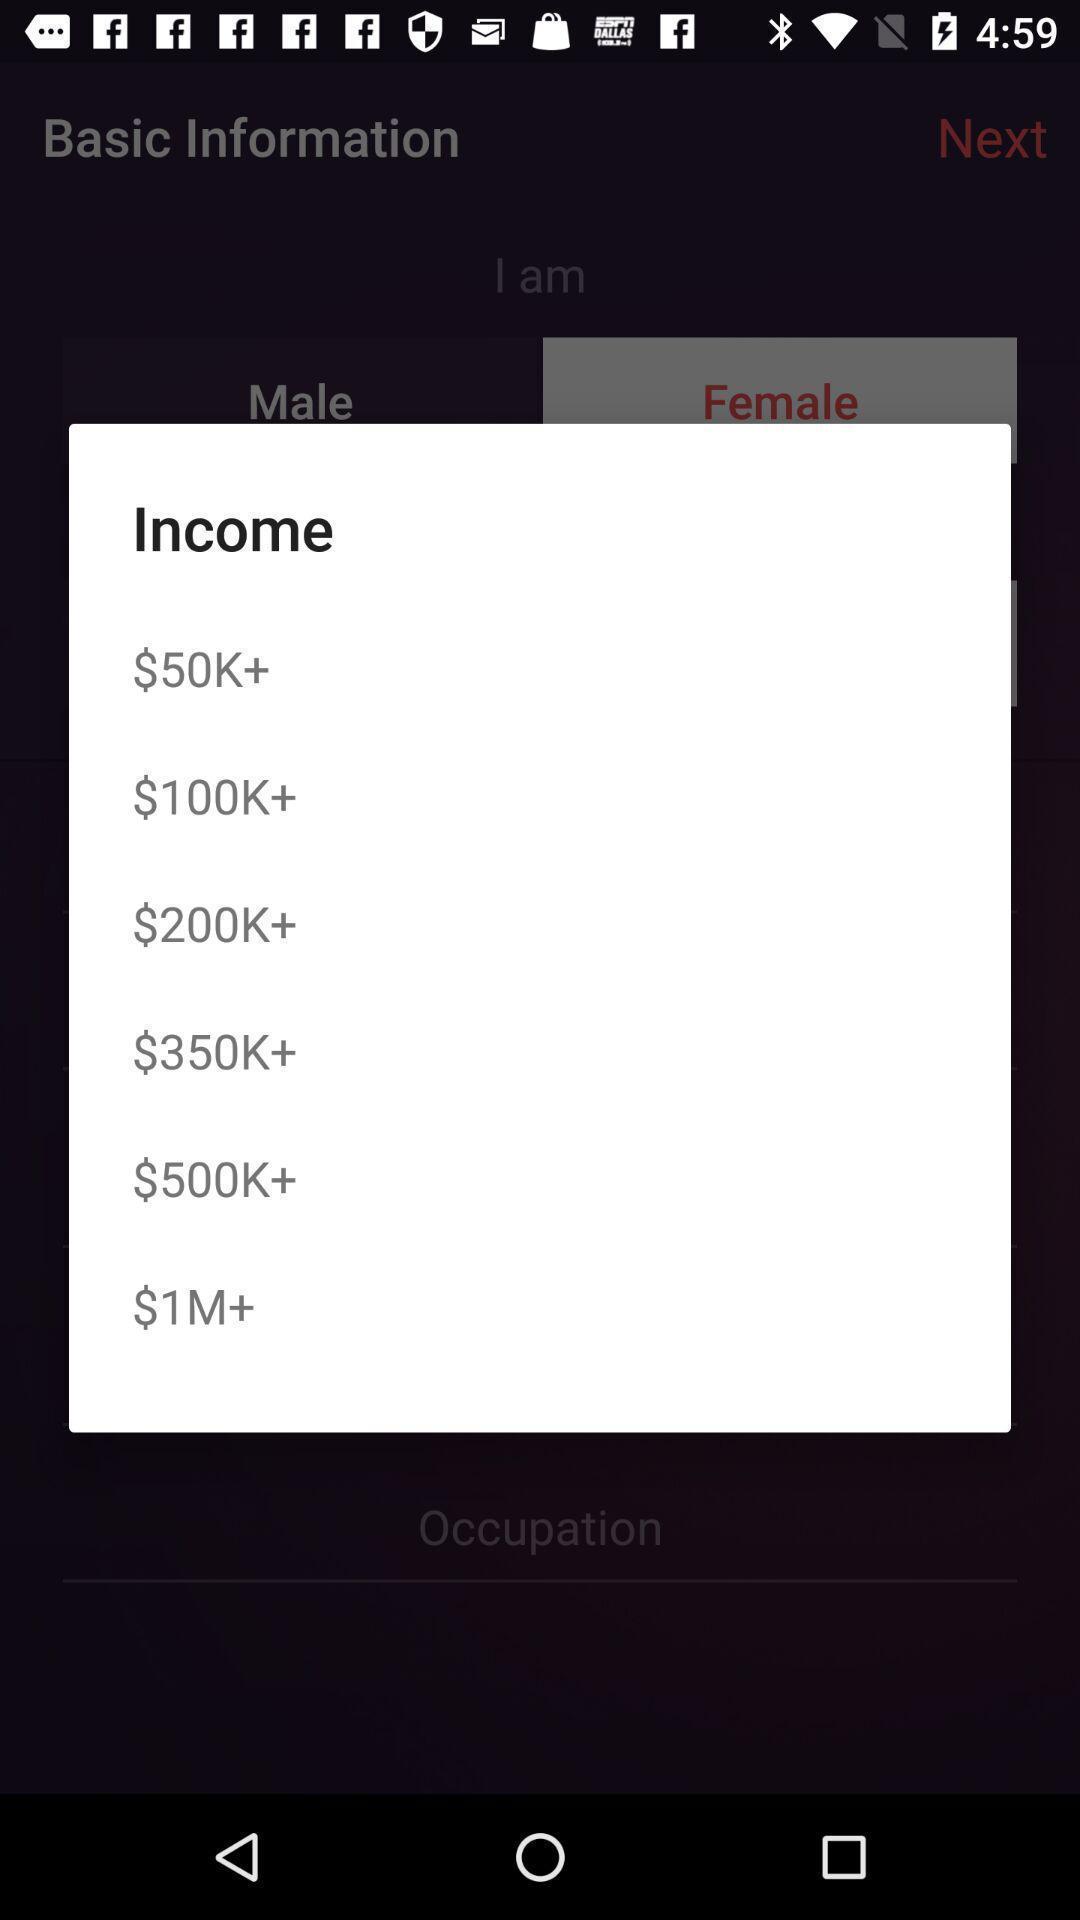What can you discern from this picture? Pop-up window showing different amounts. 